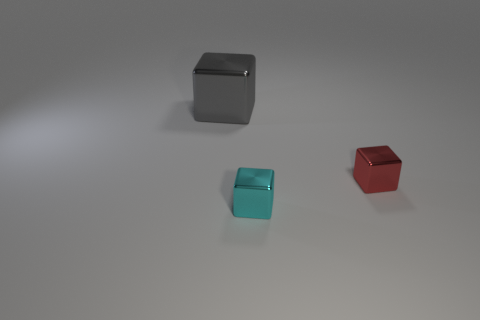What is the size of the gray metal cube?
Make the answer very short. Large. Do the big shiny thing and the thing on the right side of the cyan metallic object have the same shape?
Offer a terse response. Yes. The other tiny thing that is the same material as the small red object is what color?
Keep it short and to the point. Cyan. There is a cube on the left side of the tiny cyan cube; how big is it?
Provide a short and direct response. Large. Is the number of large gray things in front of the big gray block less than the number of big brown shiny things?
Your answer should be very brief. No. Is the number of small metal cubes less than the number of gray cubes?
Give a very brief answer. No. There is a metal object that is in front of the small metal cube that is to the right of the tiny cyan cube; what is its color?
Provide a succinct answer. Cyan. There is a thing that is on the right side of the cyan metal block; does it have the same size as the large object?
Keep it short and to the point. No. What is the material of the cyan object that is to the left of the red cube?
Provide a succinct answer. Metal. Is the number of things greater than the number of tiny red blocks?
Your answer should be very brief. Yes. 